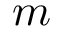<formula> <loc_0><loc_0><loc_500><loc_500>m</formula> 